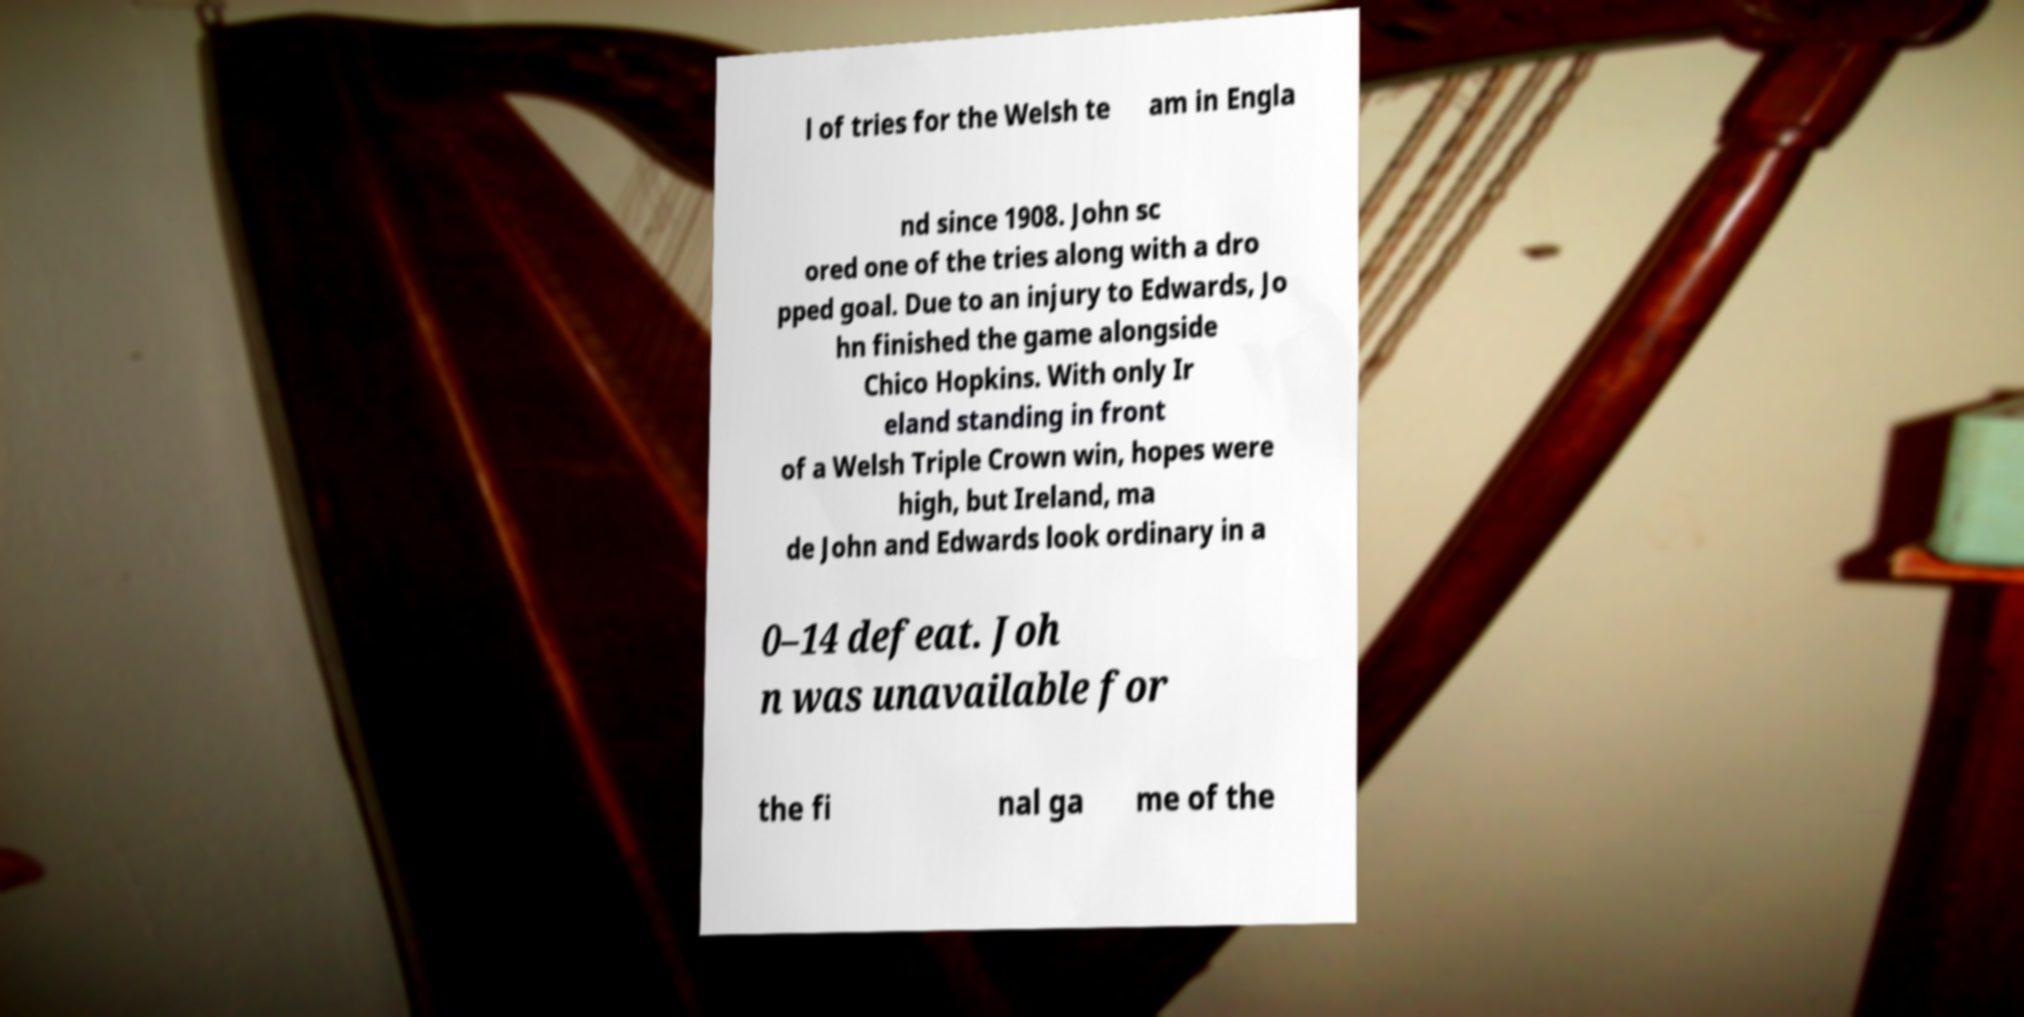Can you read and provide the text displayed in the image?This photo seems to have some interesting text. Can you extract and type it out for me? l of tries for the Welsh te am in Engla nd since 1908. John sc ored one of the tries along with a dro pped goal. Due to an injury to Edwards, Jo hn finished the game alongside Chico Hopkins. With only Ir eland standing in front of a Welsh Triple Crown win, hopes were high, but Ireland, ma de John and Edwards look ordinary in a 0–14 defeat. Joh n was unavailable for the fi nal ga me of the 